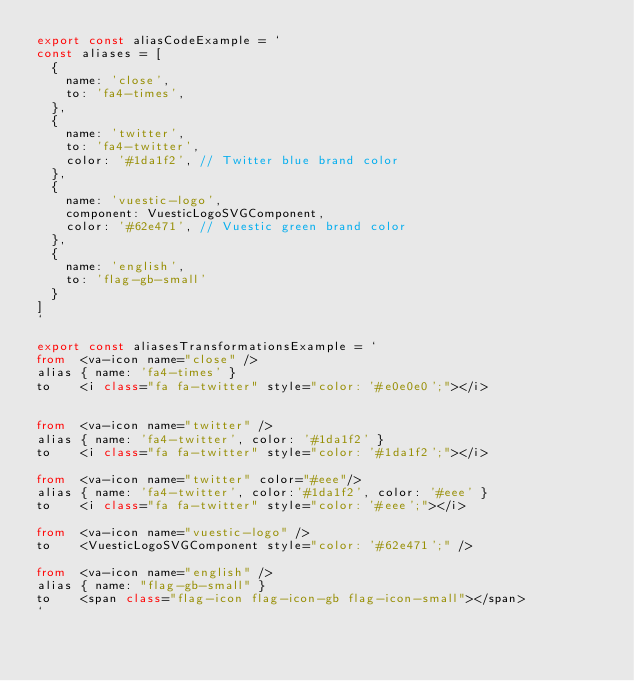Convert code to text. <code><loc_0><loc_0><loc_500><loc_500><_TypeScript_>export const aliasCodeExample = `
const aliases = [
  {
    name: 'close',
    to: 'fa4-times',
  },
  {
    name: 'twitter',
    to: 'fa4-twitter',
    color: '#1da1f2', // Twitter blue brand color
  },
  {
    name: 'vuestic-logo',
    component: VuesticLogoSVGComponent,
    color: '#62e471', // Vuestic green brand color
  },
  {
    name: 'english',
    to: 'flag-gb-small'
  }
]
`

export const aliasesTransformationsExample = `
from  <va-icon name="close" />
alias { name: 'fa4-times' }
to    <i class="fa fa-twitter" style="color: '#e0e0e0';"></i>


from  <va-icon name="twitter" />
alias { name: 'fa4-twitter', color: '#1da1f2' }
to    <i class="fa fa-twitter" style="color: '#1da1f2';"></i>

from  <va-icon name="twitter" color="#eee"/>
alias { name: 'fa4-twitter', color:'#1da1f2', color: '#eee' }
to    <i class="fa fa-twitter" style="color: '#eee';"></i>

from  <va-icon name="vuestic-logo" />
to    <VuesticLogoSVGComponent style="color: '#62e471';" />

from  <va-icon name="english" />
alias { name: "flag-gb-small" }
to    <span class="flag-icon flag-icon-gb flag-icon-small"></span>
`
</code> 